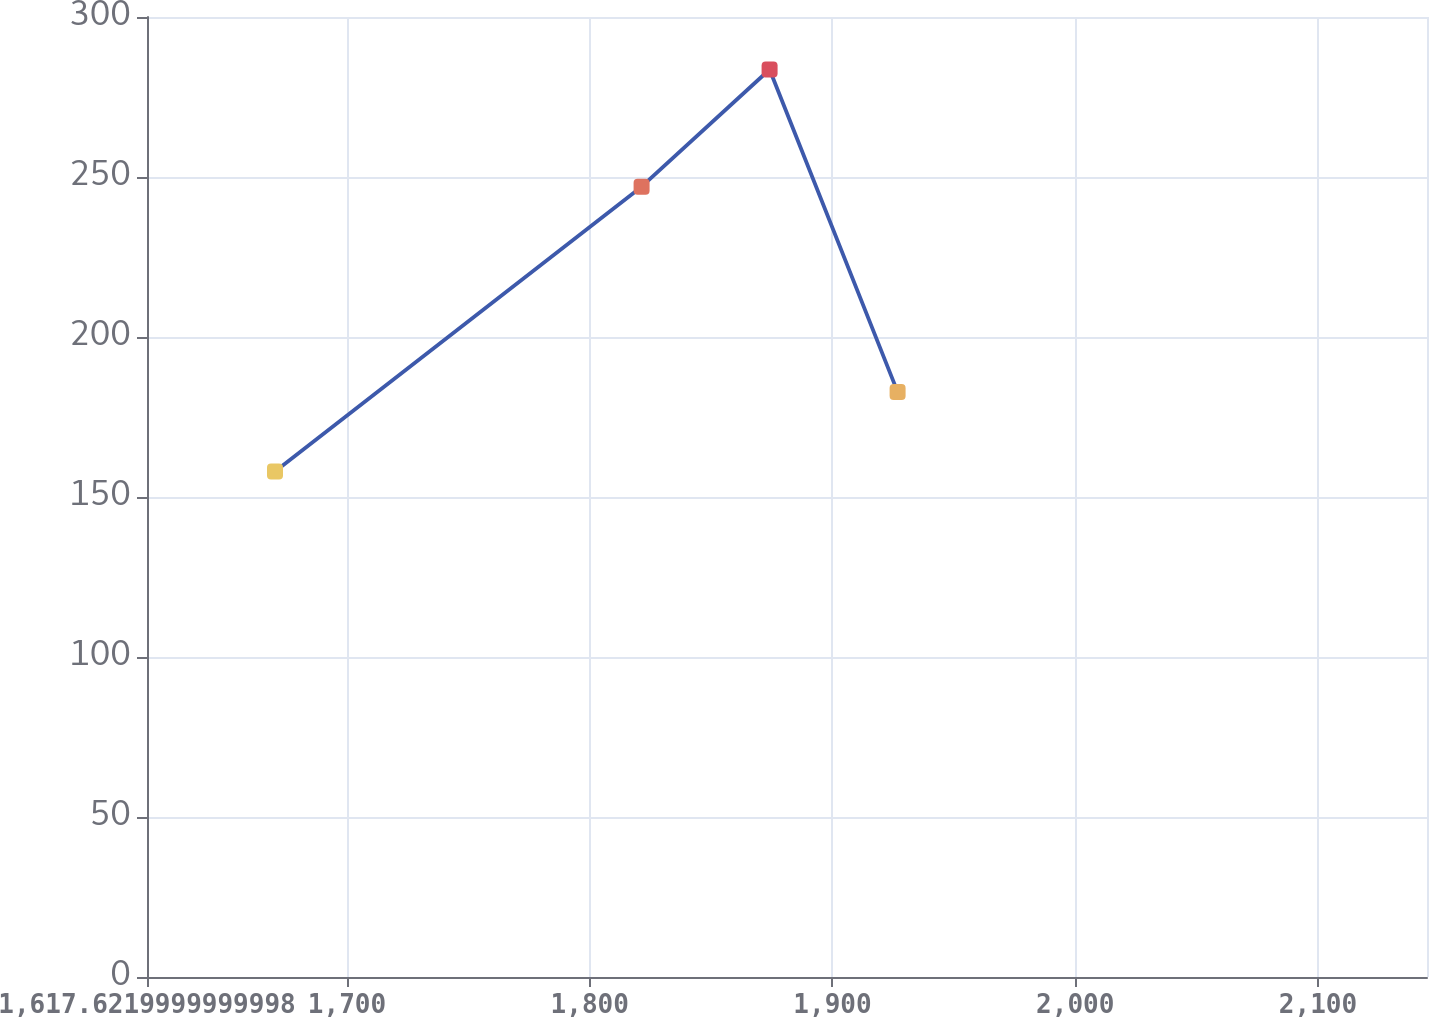Convert chart to OTSL. <chart><loc_0><loc_0><loc_500><loc_500><line_chart><ecel><fcel>Unnamed: 1<nl><fcel>1670.35<fcel>157.93<nl><fcel>1821.36<fcel>246.97<nl><fcel>1874.09<fcel>283.6<nl><fcel>1926.82<fcel>182.85<nl><fcel>2197.63<fcel>34.38<nl></chart> 